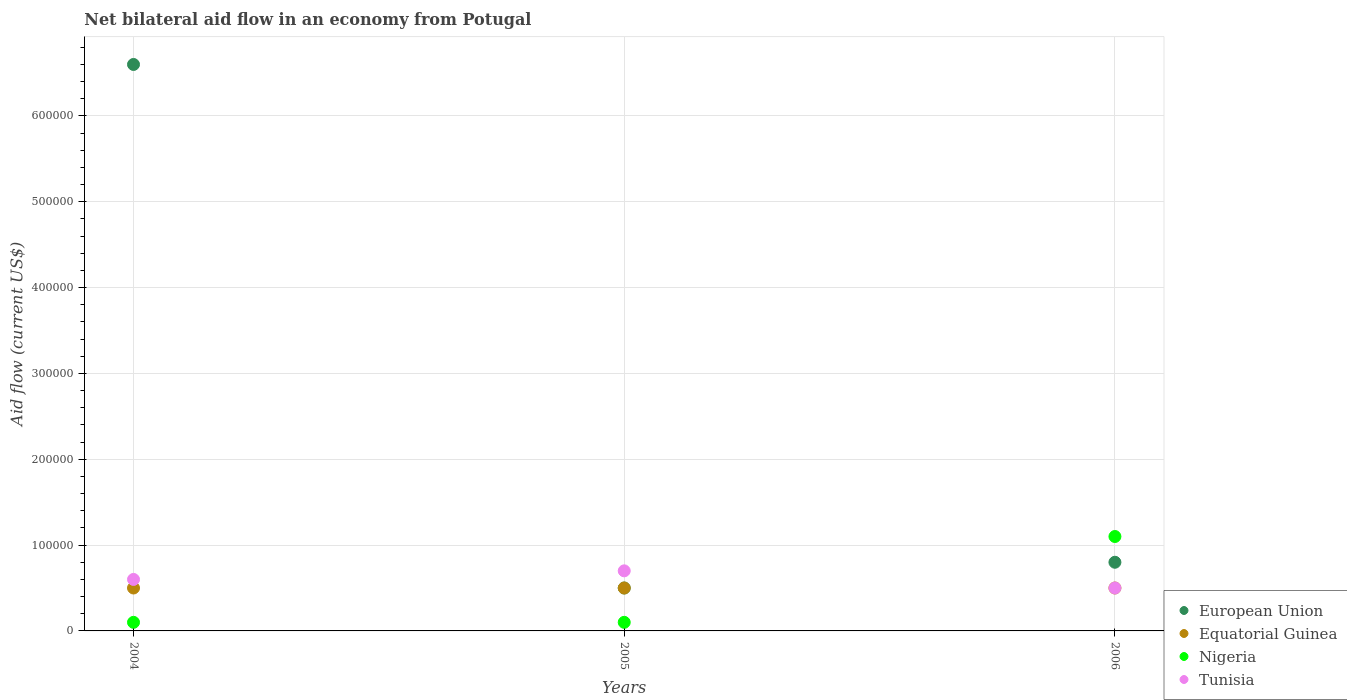Is the number of dotlines equal to the number of legend labels?
Offer a very short reply. Yes. Across all years, what is the minimum net bilateral aid flow in Tunisia?
Your answer should be very brief. 5.00e+04. In which year was the net bilateral aid flow in Nigeria minimum?
Offer a very short reply. 2004. What is the total net bilateral aid flow in Tunisia in the graph?
Offer a very short reply. 1.80e+05. What is the average net bilateral aid flow in Equatorial Guinea per year?
Make the answer very short. 5.00e+04. In the year 2004, what is the difference between the net bilateral aid flow in Tunisia and net bilateral aid flow in Nigeria?
Offer a terse response. 5.00e+04. Is the net bilateral aid flow in Tunisia in 2004 less than that in 2006?
Offer a terse response. No. What is the difference between the highest and the lowest net bilateral aid flow in Tunisia?
Give a very brief answer. 2.00e+04. In how many years, is the net bilateral aid flow in European Union greater than the average net bilateral aid flow in European Union taken over all years?
Make the answer very short. 1. Is the sum of the net bilateral aid flow in Equatorial Guinea in 2005 and 2006 greater than the maximum net bilateral aid flow in European Union across all years?
Offer a very short reply. No. Is it the case that in every year, the sum of the net bilateral aid flow in Equatorial Guinea and net bilateral aid flow in European Union  is greater than the sum of net bilateral aid flow in Tunisia and net bilateral aid flow in Nigeria?
Your response must be concise. No. Is it the case that in every year, the sum of the net bilateral aid flow in European Union and net bilateral aid flow in Tunisia  is greater than the net bilateral aid flow in Equatorial Guinea?
Offer a terse response. Yes. Does the net bilateral aid flow in Tunisia monotonically increase over the years?
Ensure brevity in your answer.  No. How many years are there in the graph?
Keep it short and to the point. 3. Does the graph contain grids?
Provide a short and direct response. Yes. How are the legend labels stacked?
Provide a succinct answer. Vertical. What is the title of the graph?
Provide a short and direct response. Net bilateral aid flow in an economy from Potugal. What is the label or title of the X-axis?
Give a very brief answer. Years. What is the label or title of the Y-axis?
Give a very brief answer. Aid flow (current US$). What is the Aid flow (current US$) in European Union in 2004?
Offer a very short reply. 6.60e+05. What is the Aid flow (current US$) of Tunisia in 2004?
Your answer should be very brief. 6.00e+04. What is the Aid flow (current US$) in Nigeria in 2005?
Keep it short and to the point. 10000. What is the Aid flow (current US$) in Tunisia in 2005?
Give a very brief answer. 7.00e+04. Across all years, what is the maximum Aid flow (current US$) of European Union?
Ensure brevity in your answer.  6.60e+05. Across all years, what is the maximum Aid flow (current US$) in Nigeria?
Provide a succinct answer. 1.10e+05. Across all years, what is the maximum Aid flow (current US$) in Tunisia?
Your answer should be very brief. 7.00e+04. Across all years, what is the minimum Aid flow (current US$) of European Union?
Make the answer very short. 5.00e+04. Across all years, what is the minimum Aid flow (current US$) of Nigeria?
Offer a terse response. 10000. What is the total Aid flow (current US$) in European Union in the graph?
Give a very brief answer. 7.90e+05. What is the total Aid flow (current US$) in Equatorial Guinea in the graph?
Provide a succinct answer. 1.50e+05. What is the total Aid flow (current US$) in Nigeria in the graph?
Make the answer very short. 1.30e+05. What is the total Aid flow (current US$) of Tunisia in the graph?
Offer a terse response. 1.80e+05. What is the difference between the Aid flow (current US$) in European Union in 2004 and that in 2005?
Provide a succinct answer. 6.10e+05. What is the difference between the Aid flow (current US$) of Tunisia in 2004 and that in 2005?
Provide a succinct answer. -10000. What is the difference between the Aid flow (current US$) in European Union in 2004 and that in 2006?
Provide a short and direct response. 5.80e+05. What is the difference between the Aid flow (current US$) in Tunisia in 2004 and that in 2006?
Your answer should be very brief. 10000. What is the difference between the Aid flow (current US$) of European Union in 2005 and that in 2006?
Give a very brief answer. -3.00e+04. What is the difference between the Aid flow (current US$) of Equatorial Guinea in 2005 and that in 2006?
Offer a terse response. 0. What is the difference between the Aid flow (current US$) in Nigeria in 2005 and that in 2006?
Offer a very short reply. -1.00e+05. What is the difference between the Aid flow (current US$) of Tunisia in 2005 and that in 2006?
Offer a very short reply. 2.00e+04. What is the difference between the Aid flow (current US$) of European Union in 2004 and the Aid flow (current US$) of Nigeria in 2005?
Provide a succinct answer. 6.50e+05. What is the difference between the Aid flow (current US$) of European Union in 2004 and the Aid flow (current US$) of Tunisia in 2005?
Provide a succinct answer. 5.90e+05. What is the difference between the Aid flow (current US$) in Nigeria in 2004 and the Aid flow (current US$) in Tunisia in 2005?
Keep it short and to the point. -6.00e+04. What is the difference between the Aid flow (current US$) of European Union in 2004 and the Aid flow (current US$) of Nigeria in 2006?
Provide a succinct answer. 5.50e+05. What is the difference between the Aid flow (current US$) of Nigeria in 2004 and the Aid flow (current US$) of Tunisia in 2006?
Your response must be concise. -4.00e+04. What is the difference between the Aid flow (current US$) of European Union in 2005 and the Aid flow (current US$) of Nigeria in 2006?
Your answer should be very brief. -6.00e+04. What is the difference between the Aid flow (current US$) in European Union in 2005 and the Aid flow (current US$) in Tunisia in 2006?
Provide a short and direct response. 0. What is the difference between the Aid flow (current US$) in Equatorial Guinea in 2005 and the Aid flow (current US$) in Nigeria in 2006?
Your answer should be compact. -6.00e+04. What is the difference between the Aid flow (current US$) of Equatorial Guinea in 2005 and the Aid flow (current US$) of Tunisia in 2006?
Your response must be concise. 0. What is the difference between the Aid flow (current US$) in Nigeria in 2005 and the Aid flow (current US$) in Tunisia in 2006?
Keep it short and to the point. -4.00e+04. What is the average Aid flow (current US$) of European Union per year?
Provide a succinct answer. 2.63e+05. What is the average Aid flow (current US$) of Equatorial Guinea per year?
Offer a terse response. 5.00e+04. What is the average Aid flow (current US$) of Nigeria per year?
Your response must be concise. 4.33e+04. What is the average Aid flow (current US$) in Tunisia per year?
Offer a very short reply. 6.00e+04. In the year 2004, what is the difference between the Aid flow (current US$) of European Union and Aid flow (current US$) of Nigeria?
Offer a very short reply. 6.50e+05. In the year 2004, what is the difference between the Aid flow (current US$) of European Union and Aid flow (current US$) of Tunisia?
Ensure brevity in your answer.  6.00e+05. In the year 2004, what is the difference between the Aid flow (current US$) of Equatorial Guinea and Aid flow (current US$) of Tunisia?
Provide a succinct answer. -10000. In the year 2004, what is the difference between the Aid flow (current US$) in Nigeria and Aid flow (current US$) in Tunisia?
Keep it short and to the point. -5.00e+04. In the year 2005, what is the difference between the Aid flow (current US$) of European Union and Aid flow (current US$) of Equatorial Guinea?
Your answer should be very brief. 0. In the year 2005, what is the difference between the Aid flow (current US$) in European Union and Aid flow (current US$) in Tunisia?
Keep it short and to the point. -2.00e+04. In the year 2006, what is the difference between the Aid flow (current US$) of European Union and Aid flow (current US$) of Equatorial Guinea?
Give a very brief answer. 3.00e+04. In the year 2006, what is the difference between the Aid flow (current US$) of European Union and Aid flow (current US$) of Nigeria?
Your answer should be compact. -3.00e+04. In the year 2006, what is the difference between the Aid flow (current US$) in European Union and Aid flow (current US$) in Tunisia?
Keep it short and to the point. 3.00e+04. In the year 2006, what is the difference between the Aid flow (current US$) in Equatorial Guinea and Aid flow (current US$) in Nigeria?
Keep it short and to the point. -6.00e+04. In the year 2006, what is the difference between the Aid flow (current US$) in Nigeria and Aid flow (current US$) in Tunisia?
Give a very brief answer. 6.00e+04. What is the ratio of the Aid flow (current US$) of European Union in 2004 to that in 2005?
Keep it short and to the point. 13.2. What is the ratio of the Aid flow (current US$) of Equatorial Guinea in 2004 to that in 2005?
Offer a very short reply. 1. What is the ratio of the Aid flow (current US$) in Tunisia in 2004 to that in 2005?
Offer a very short reply. 0.86. What is the ratio of the Aid flow (current US$) in European Union in 2004 to that in 2006?
Ensure brevity in your answer.  8.25. What is the ratio of the Aid flow (current US$) in Nigeria in 2004 to that in 2006?
Your answer should be compact. 0.09. What is the ratio of the Aid flow (current US$) of Nigeria in 2005 to that in 2006?
Keep it short and to the point. 0.09. What is the ratio of the Aid flow (current US$) of Tunisia in 2005 to that in 2006?
Ensure brevity in your answer.  1.4. What is the difference between the highest and the second highest Aid flow (current US$) in European Union?
Provide a short and direct response. 5.80e+05. What is the difference between the highest and the second highest Aid flow (current US$) of Equatorial Guinea?
Your answer should be compact. 0. What is the difference between the highest and the second highest Aid flow (current US$) in Nigeria?
Ensure brevity in your answer.  1.00e+05. What is the difference between the highest and the lowest Aid flow (current US$) of Equatorial Guinea?
Ensure brevity in your answer.  0. 